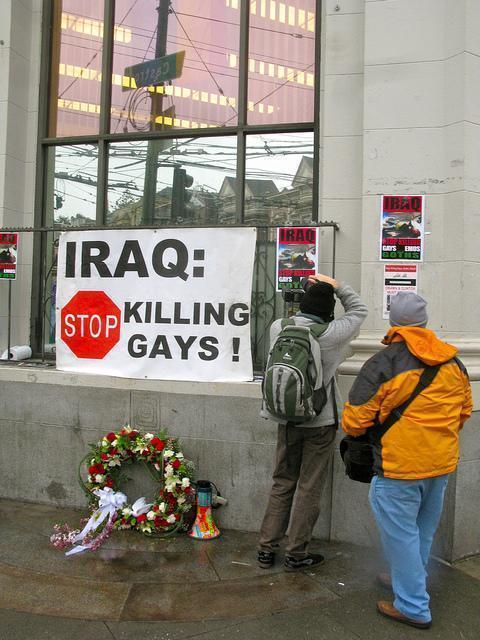What type of death might the Wreath commemorate?
Answer the question by selecting the correct answer among the 4 following choices.
Options: Iraqi president, soldier, gay person, enemy fighter. Gay person. 